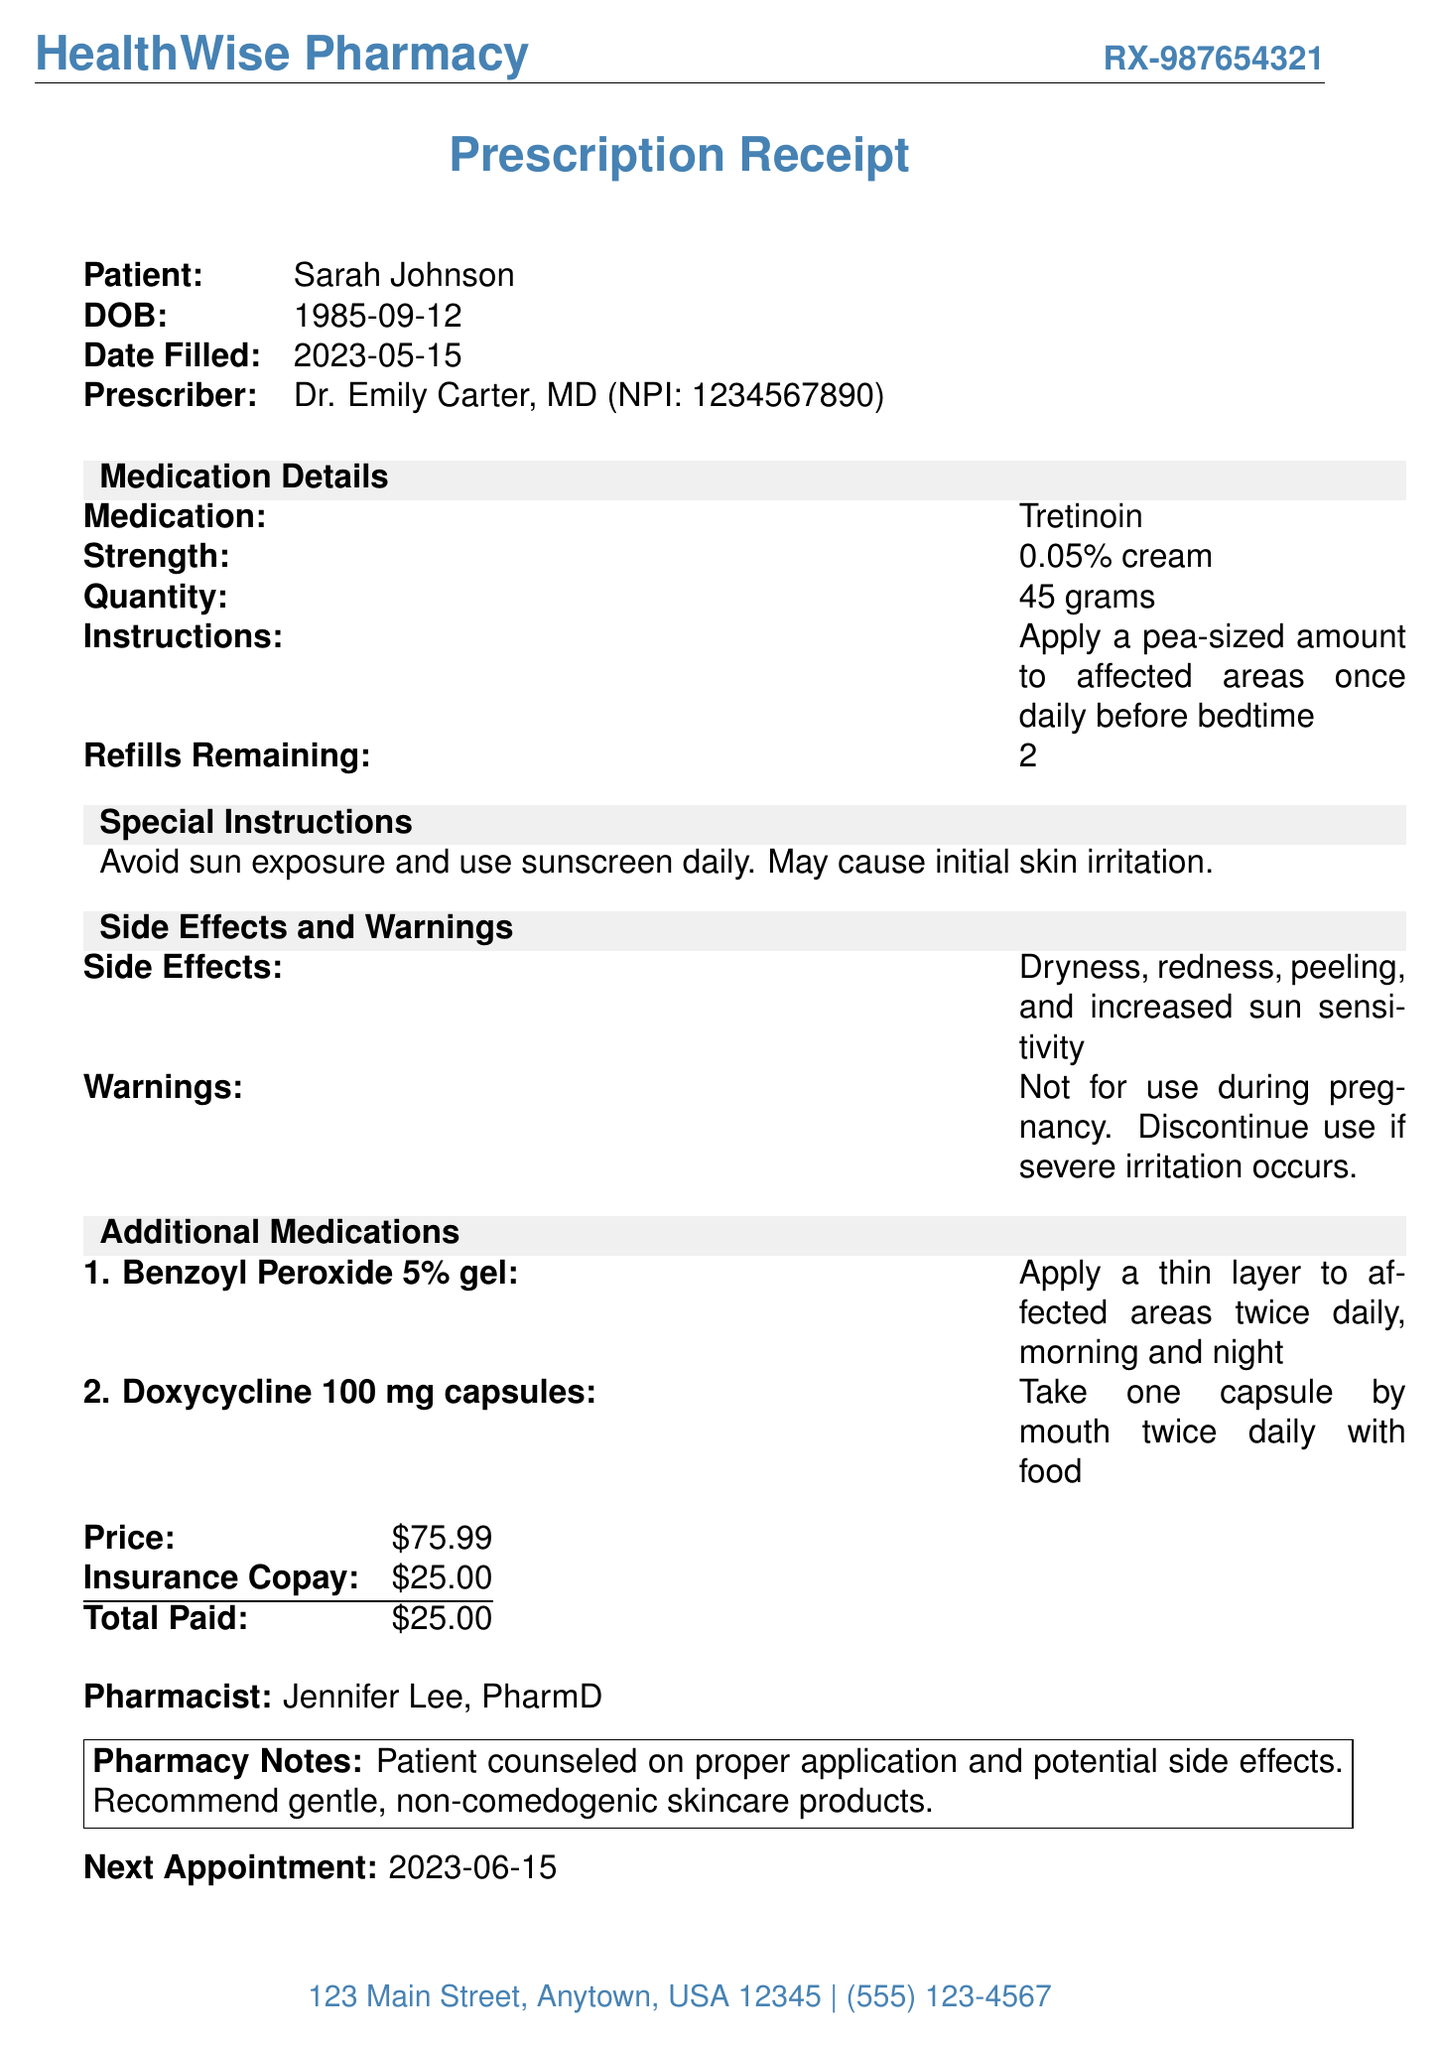What is the name of the pharmacy? The name of the pharmacy is listed at the top of the document under the pharmacy information.
Answer: HealthWise Pharmacy What is the date the prescription was filled? The date filled is indicated next to the relevant label in the document.
Answer: 2023-05-15 Who is the prescribing doctor? The prescriber's information, including name, is provided in the patient details section.
Answer: Dr. Emily Carter, MD What is the quantity of the medication prescribed? The quantity of the medication is referenced under the medication details section in the document.
Answer: 45 grams What are the side effects of Tretinoin? The side effects are specifically mentioned in the side effects and warnings section of the document.
Answer: Dryness, redness, peeling, and increased sun sensitivity What is the dosage instruction for Benzoyl Peroxide? The dosage instruction is described under the additional medications section in the document.
Answer: Apply a thin layer to affected areas twice daily, morning and night How much is the insurance copay? The amount for the insurance copay is listed within the price-related table in the document.
Answer: $25.00 How many refills are remaining for the prescription? The number of refills remaining is noted under the medication details section of the receipt.
Answer: 2 What is the date of the next appointment? The next appointment date is mentioned at the bottom of the document under a specific label.
Answer: 2023-06-15 